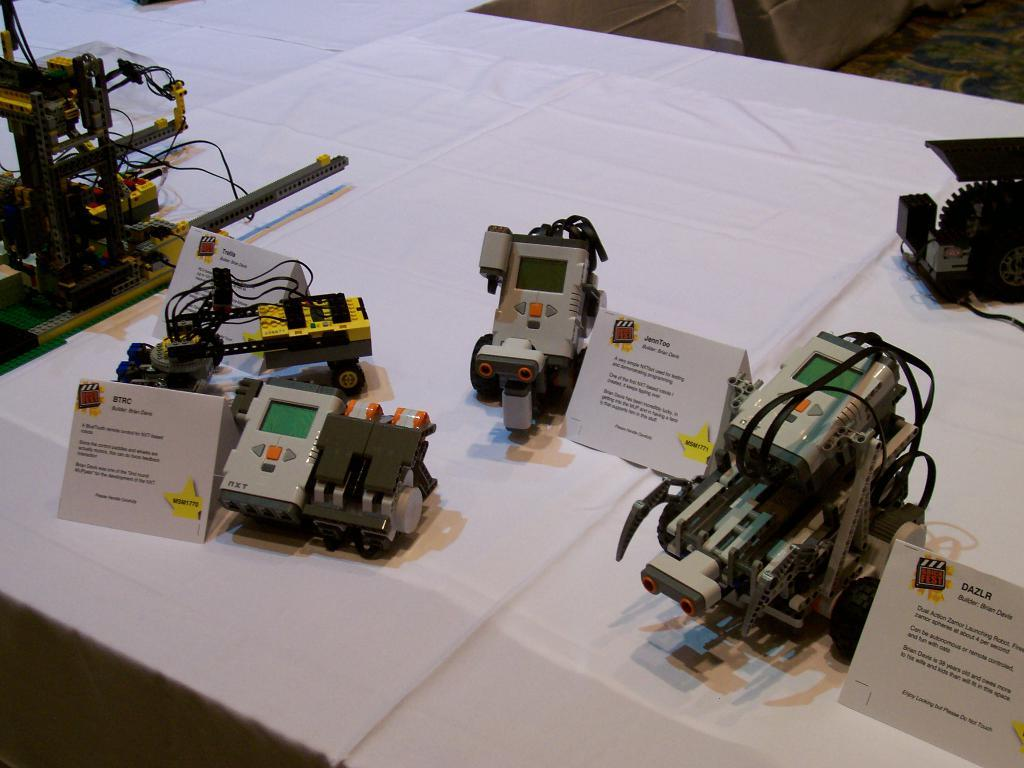What type of objects can be seen in the image? There are machines and boards in the image. How are the machines and boards arranged in the image? The machines and boards are placed on a white cloth. What colors can be observed on the machines? The machines have gray and yellow colors. What type of error message is displayed on the boards in the image? There is no error message displayed on the boards in the image; the boards are just plain boards. What role does the government play in the machines and boards in the image? The government is not mentioned or depicted in the image, so it is not possible to determine its role in relation to the machines and boards. 